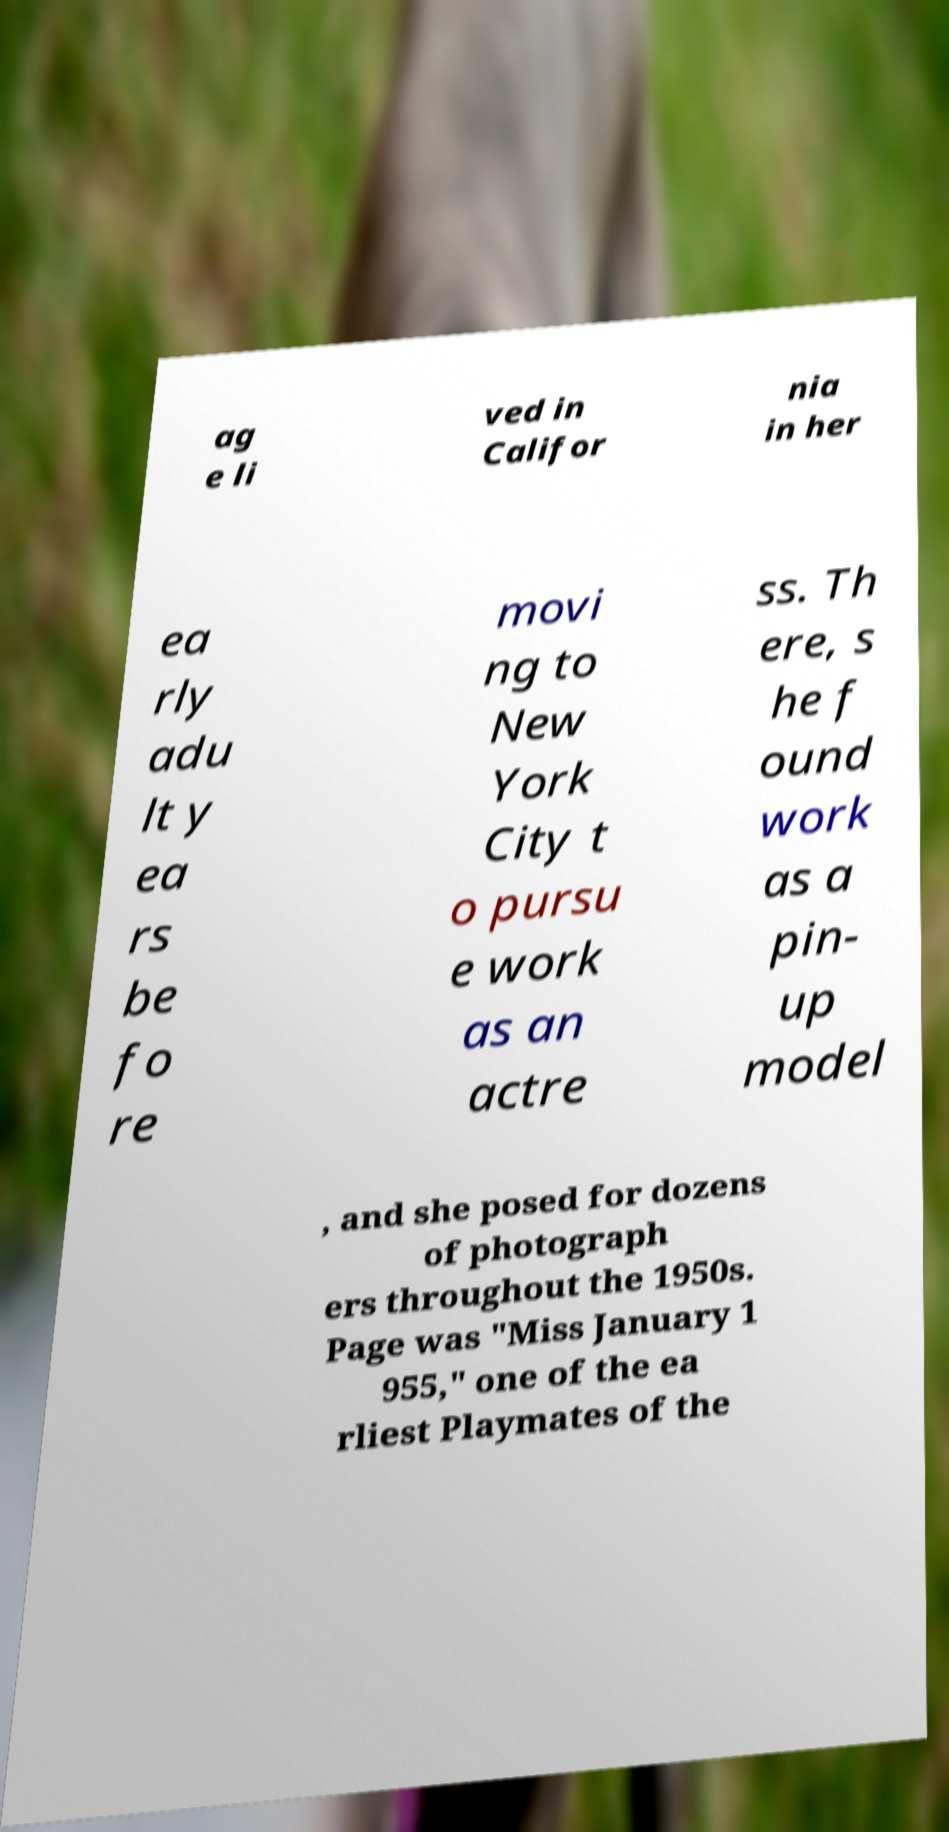For documentation purposes, I need the text within this image transcribed. Could you provide that? ag e li ved in Califor nia in her ea rly adu lt y ea rs be fo re movi ng to New York City t o pursu e work as an actre ss. Th ere, s he f ound work as a pin- up model , and she posed for dozens of photograph ers throughout the 1950s. Page was "Miss January 1 955," one of the ea rliest Playmates of the 